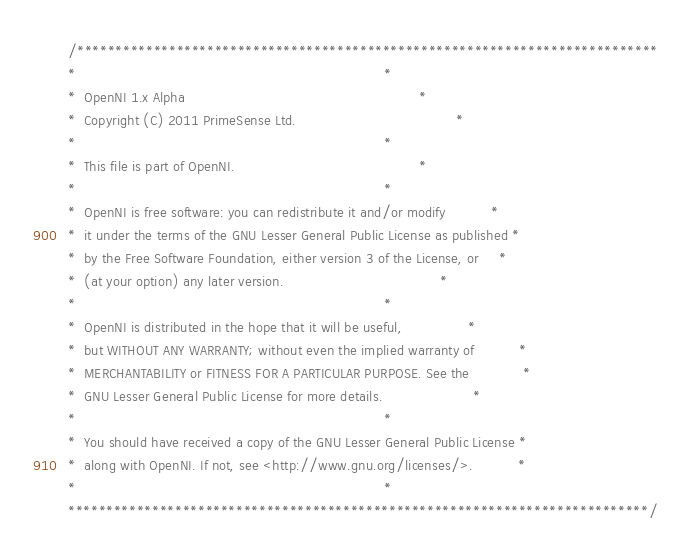<code> <loc_0><loc_0><loc_500><loc_500><_C++_>/****************************************************************************
*                                                                           *
*  OpenNI 1.x Alpha                                                         *
*  Copyright (C) 2011 PrimeSense Ltd.                                       *
*                                                                           *
*  This file is part of OpenNI.                                             *
*                                                                           *
*  OpenNI is free software: you can redistribute it and/or modify           *
*  it under the terms of the GNU Lesser General Public License as published *
*  by the Free Software Foundation, either version 3 of the License, or     *
*  (at your option) any later version.                                      *
*                                                                           *
*  OpenNI is distributed in the hope that it will be useful,                *
*  but WITHOUT ANY WARRANTY; without even the implied warranty of           *
*  MERCHANTABILITY or FITNESS FOR A PARTICULAR PURPOSE. See the             *
*  GNU Lesser General Public License for more details.                      *
*                                                                           *
*  You should have received a copy of the GNU Lesser General Public License *
*  along with OpenNI. If not, see <http://www.gnu.org/licenses/>.           *
*                                                                           *
****************************************************************************/</code> 